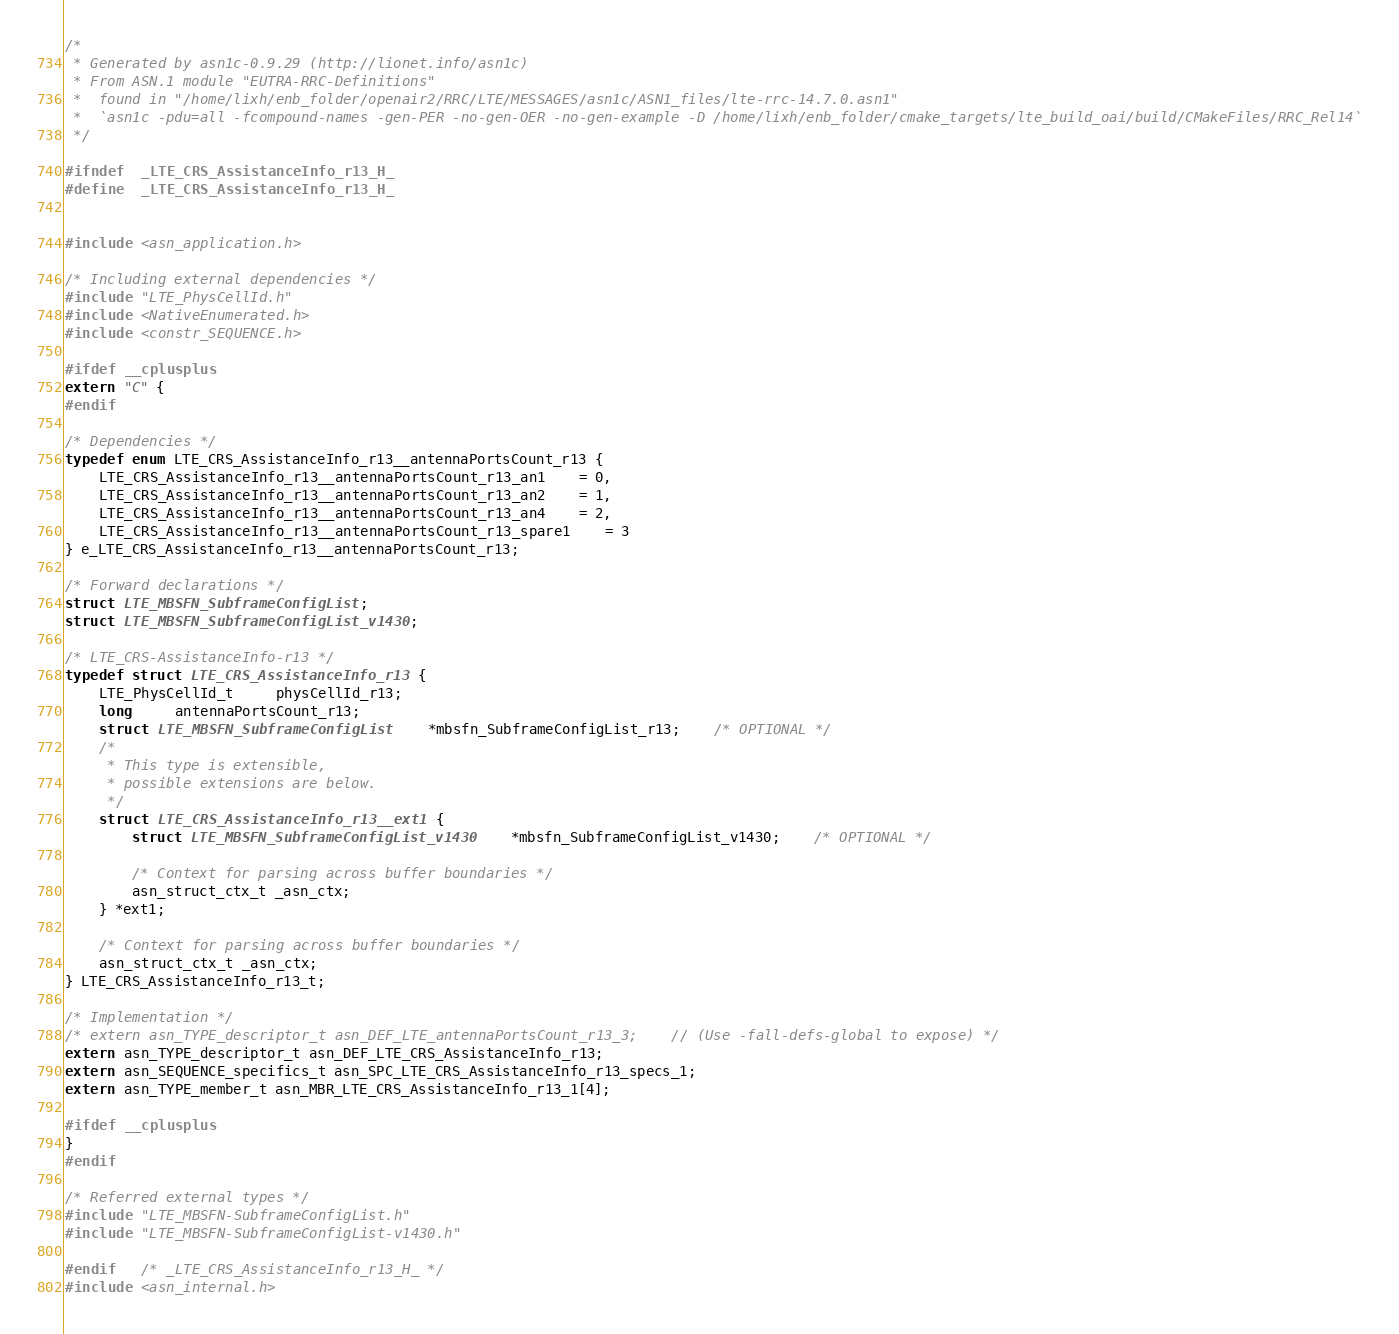Convert code to text. <code><loc_0><loc_0><loc_500><loc_500><_C_>/*
 * Generated by asn1c-0.9.29 (http://lionet.info/asn1c)
 * From ASN.1 module "EUTRA-RRC-Definitions"
 * 	found in "/home/lixh/enb_folder/openair2/RRC/LTE/MESSAGES/asn1c/ASN1_files/lte-rrc-14.7.0.asn1"
 * 	`asn1c -pdu=all -fcompound-names -gen-PER -no-gen-OER -no-gen-example -D /home/lixh/enb_folder/cmake_targets/lte_build_oai/build/CMakeFiles/RRC_Rel14`
 */

#ifndef	_LTE_CRS_AssistanceInfo_r13_H_
#define	_LTE_CRS_AssistanceInfo_r13_H_


#include <asn_application.h>

/* Including external dependencies */
#include "LTE_PhysCellId.h"
#include <NativeEnumerated.h>
#include <constr_SEQUENCE.h>

#ifdef __cplusplus
extern "C" {
#endif

/* Dependencies */
typedef enum LTE_CRS_AssistanceInfo_r13__antennaPortsCount_r13 {
	LTE_CRS_AssistanceInfo_r13__antennaPortsCount_r13_an1	= 0,
	LTE_CRS_AssistanceInfo_r13__antennaPortsCount_r13_an2	= 1,
	LTE_CRS_AssistanceInfo_r13__antennaPortsCount_r13_an4	= 2,
	LTE_CRS_AssistanceInfo_r13__antennaPortsCount_r13_spare1	= 3
} e_LTE_CRS_AssistanceInfo_r13__antennaPortsCount_r13;

/* Forward declarations */
struct LTE_MBSFN_SubframeConfigList;
struct LTE_MBSFN_SubframeConfigList_v1430;

/* LTE_CRS-AssistanceInfo-r13 */
typedef struct LTE_CRS_AssistanceInfo_r13 {
	LTE_PhysCellId_t	 physCellId_r13;
	long	 antennaPortsCount_r13;
	struct LTE_MBSFN_SubframeConfigList	*mbsfn_SubframeConfigList_r13;	/* OPTIONAL */
	/*
	 * This type is extensible,
	 * possible extensions are below.
	 */
	struct LTE_CRS_AssistanceInfo_r13__ext1 {
		struct LTE_MBSFN_SubframeConfigList_v1430	*mbsfn_SubframeConfigList_v1430;	/* OPTIONAL */
		
		/* Context for parsing across buffer boundaries */
		asn_struct_ctx_t _asn_ctx;
	} *ext1;
	
	/* Context for parsing across buffer boundaries */
	asn_struct_ctx_t _asn_ctx;
} LTE_CRS_AssistanceInfo_r13_t;

/* Implementation */
/* extern asn_TYPE_descriptor_t asn_DEF_LTE_antennaPortsCount_r13_3;	// (Use -fall-defs-global to expose) */
extern asn_TYPE_descriptor_t asn_DEF_LTE_CRS_AssistanceInfo_r13;
extern asn_SEQUENCE_specifics_t asn_SPC_LTE_CRS_AssistanceInfo_r13_specs_1;
extern asn_TYPE_member_t asn_MBR_LTE_CRS_AssistanceInfo_r13_1[4];

#ifdef __cplusplus
}
#endif

/* Referred external types */
#include "LTE_MBSFN-SubframeConfigList.h"
#include "LTE_MBSFN-SubframeConfigList-v1430.h"

#endif	/* _LTE_CRS_AssistanceInfo_r13_H_ */
#include <asn_internal.h>
</code> 